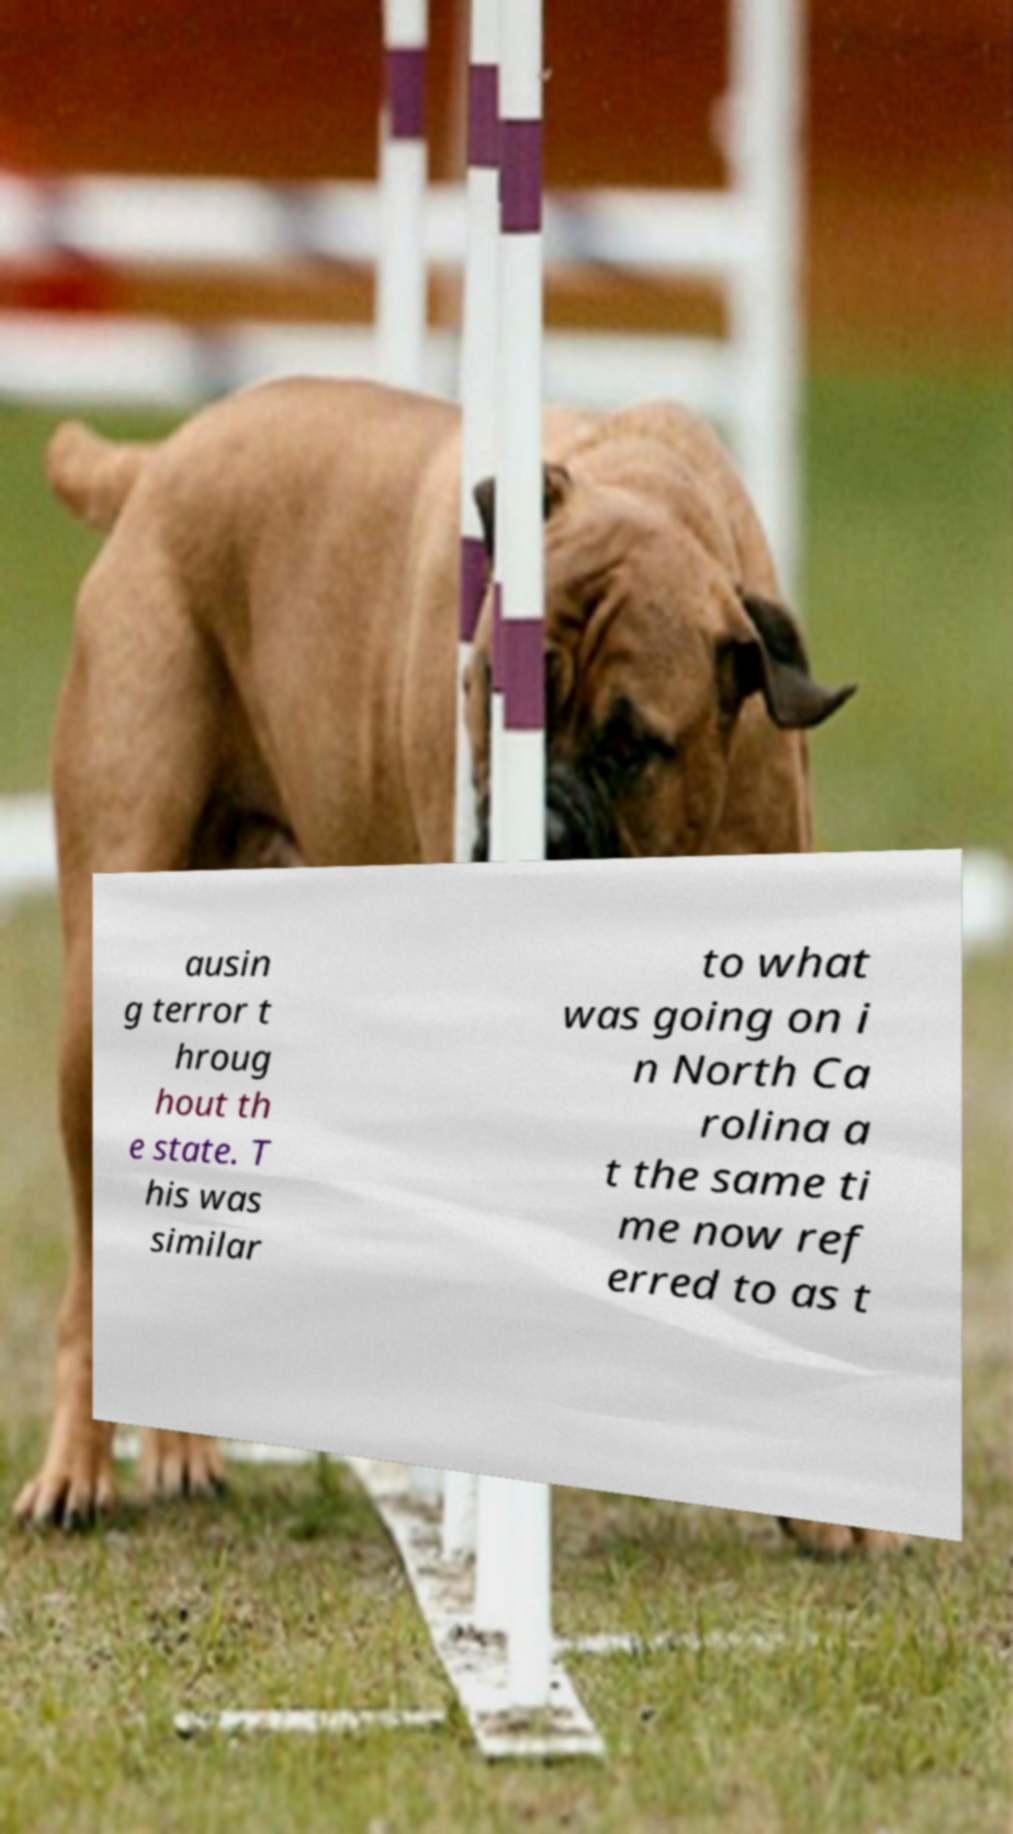Please read and relay the text visible in this image. What does it say? ausin g terror t hroug hout th e state. T his was similar to what was going on i n North Ca rolina a t the same ti me now ref erred to as t 